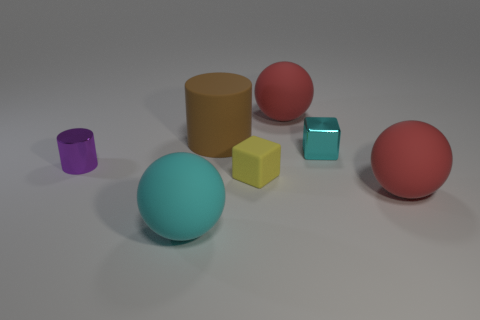Add 3 tiny cyan shiny cubes. How many objects exist? 10 Subtract all cubes. How many objects are left? 5 Add 6 small matte things. How many small matte things are left? 7 Add 3 tiny cyan shiny objects. How many tiny cyan shiny objects exist? 4 Subtract 1 cyan cubes. How many objects are left? 6 Subtract all brown cylinders. Subtract all tiny yellow matte cubes. How many objects are left? 5 